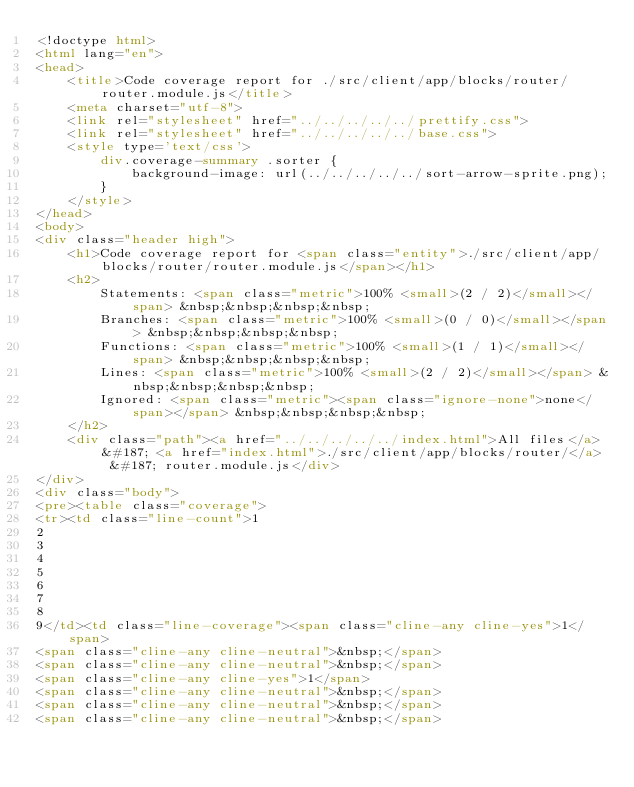Convert code to text. <code><loc_0><loc_0><loc_500><loc_500><_HTML_><!doctype html>
<html lang="en">
<head>
    <title>Code coverage report for ./src/client/app/blocks/router/router.module.js</title>
    <meta charset="utf-8">
    <link rel="stylesheet" href="../../../../../prettify.css">
    <link rel="stylesheet" href="../../../../../base.css">
    <style type='text/css'>
        div.coverage-summary .sorter {
            background-image: url(../../../../../sort-arrow-sprite.png);
        }
    </style>
</head>
<body>
<div class="header high">
    <h1>Code coverage report for <span class="entity">./src/client/app/blocks/router/router.module.js</span></h1>
    <h2>
        Statements: <span class="metric">100% <small>(2 / 2)</small></span> &nbsp;&nbsp;&nbsp;&nbsp;
        Branches: <span class="metric">100% <small>(0 / 0)</small></span> &nbsp;&nbsp;&nbsp;&nbsp;
        Functions: <span class="metric">100% <small>(1 / 1)</small></span> &nbsp;&nbsp;&nbsp;&nbsp;
        Lines: <span class="metric">100% <small>(2 / 2)</small></span> &nbsp;&nbsp;&nbsp;&nbsp;
        Ignored: <span class="metric"><span class="ignore-none">none</span></span> &nbsp;&nbsp;&nbsp;&nbsp;
    </h2>
    <div class="path"><a href="../../../../../index.html">All files</a> &#187; <a href="index.html">./src/client/app/blocks/router/</a> &#187; router.module.js</div>
</div>
<div class="body">
<pre><table class="coverage">
<tr><td class="line-count">1
2
3
4
5
6
7
8
9</td><td class="line-coverage"><span class="cline-any cline-yes">1</span>
<span class="cline-any cline-neutral">&nbsp;</span>
<span class="cline-any cline-neutral">&nbsp;</span>
<span class="cline-any cline-yes">1</span>
<span class="cline-any cline-neutral">&nbsp;</span>
<span class="cline-any cline-neutral">&nbsp;</span>
<span class="cline-any cline-neutral">&nbsp;</span></code> 